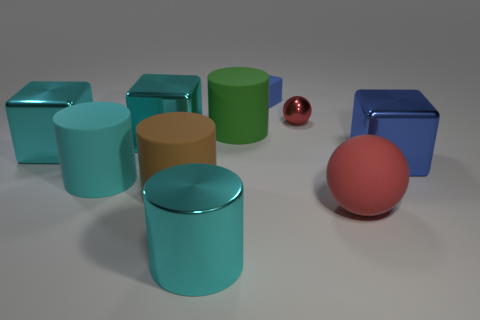What's the position of the blue blocks relative to the other cylinders? One blue block is positioned just right of center towards the front, and another is towards the back right in the image. Both blue blocks are situated among cylinders of different hues, with the second block more towards the cylinders' edges. 